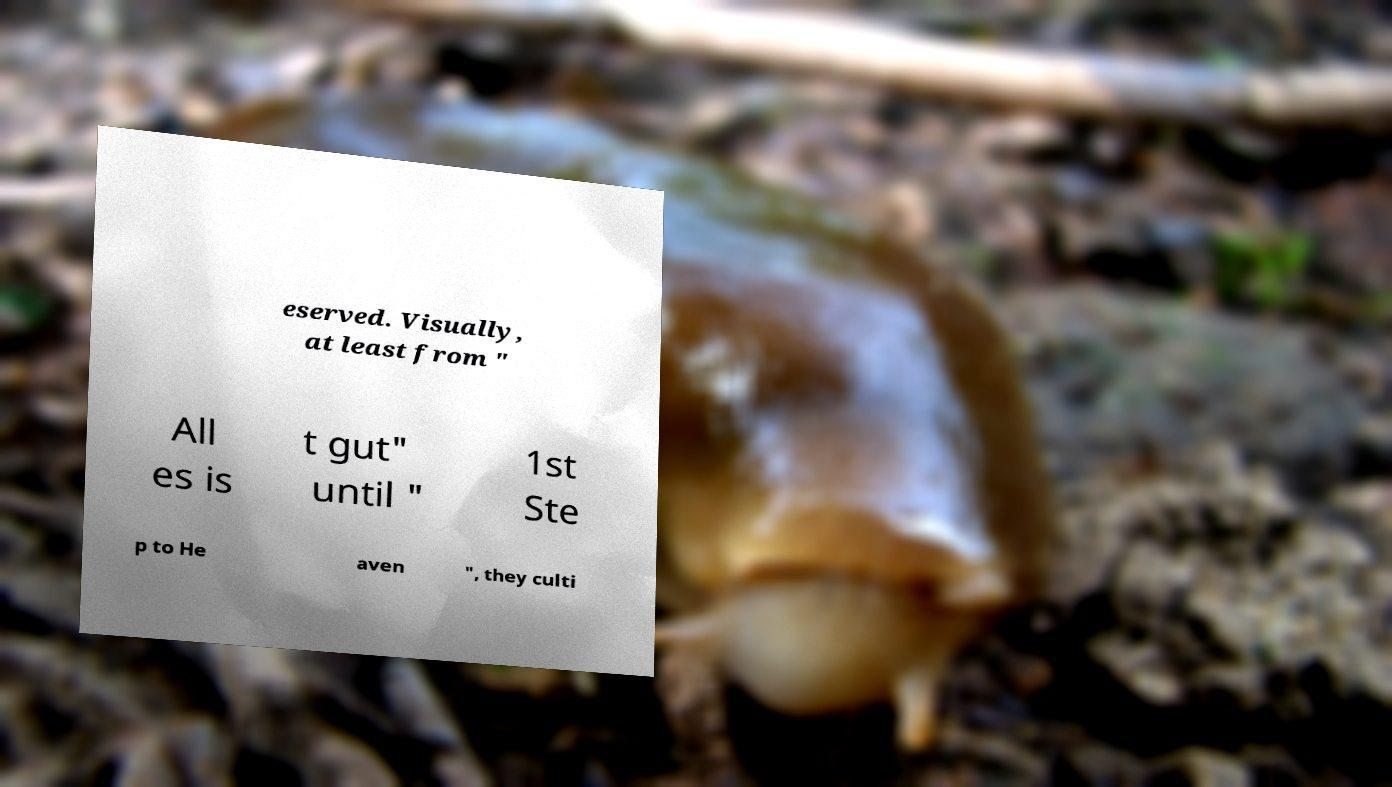I need the written content from this picture converted into text. Can you do that? eserved. Visually, at least from " All es is t gut" until " 1st Ste p to He aven ", they culti 